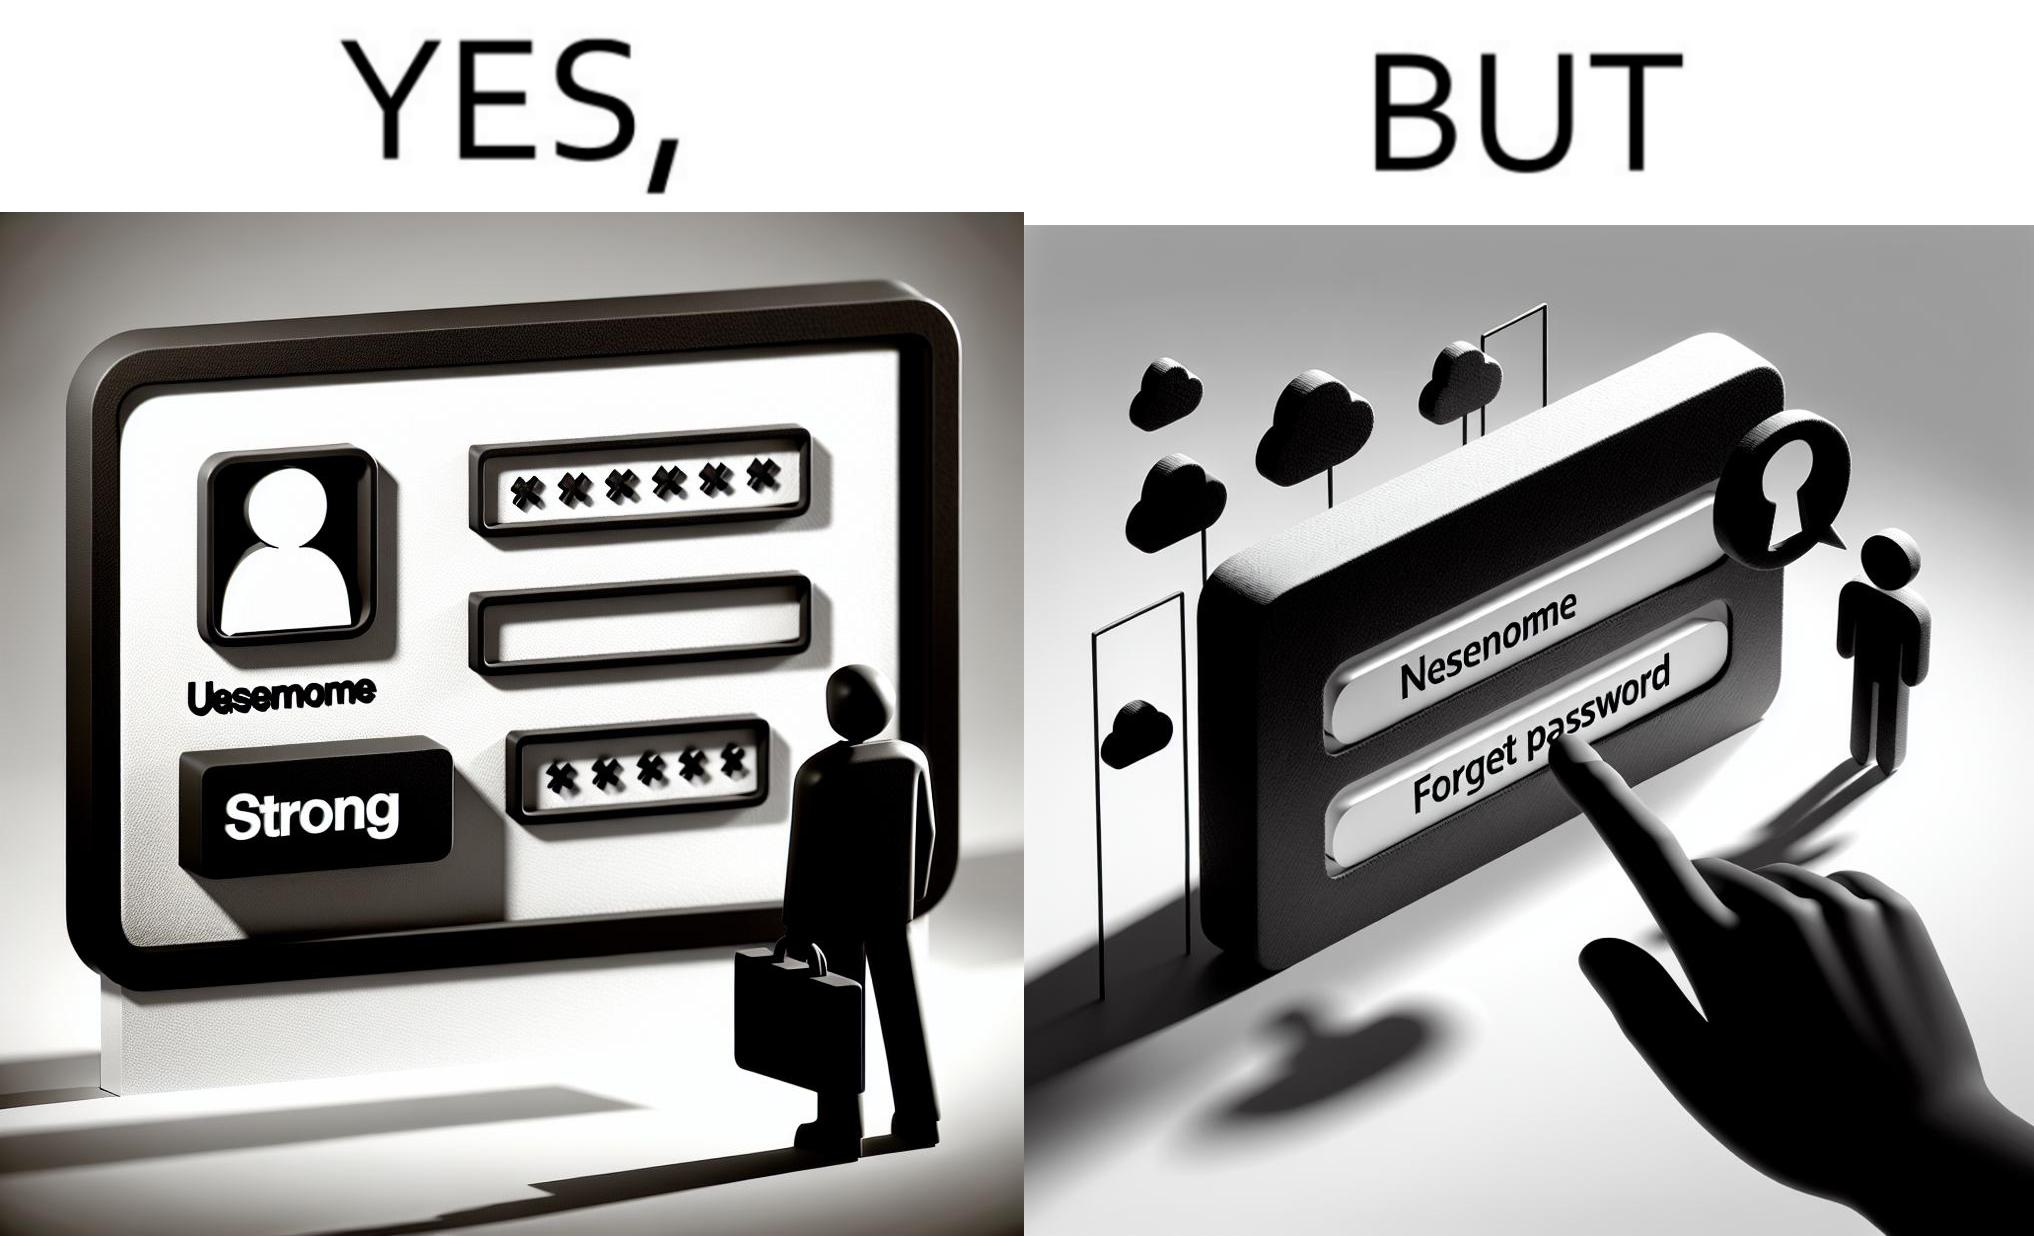Describe what you see in the left and right parts of this image. In the left part of the image: a screenshot of an account creation page of some site with login details filled in such as username and create password and password strength checker showing password as "strong" In the right part of the image: a screenshot of a login page of some site with username filled in and the user about to click on "Forget Password" link as the pointer is over the link 